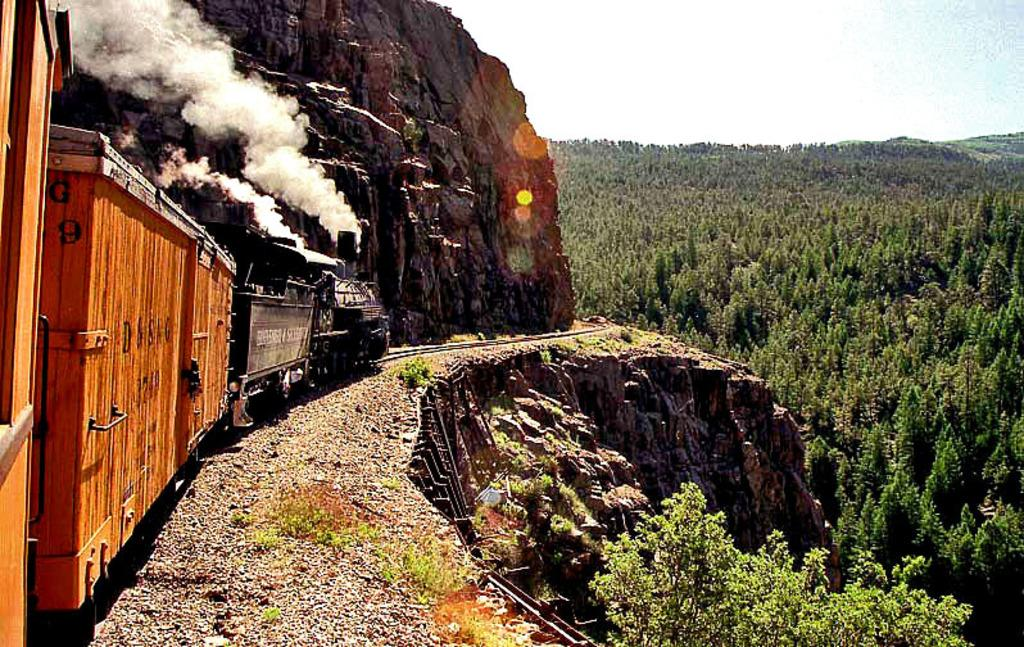What is the main subject of the image? The main subject of the image is a track on a mountain. What is located on the track in the image? There is a train on the track. What can be seen in the background of the image? There are trees and the sky visible in the background of the image. What type of skate is being used by the train in the image? There is no skate present in the image; the train is on a track. Can you see any cracks in the train or the track in the image? The image does not show any cracks in the train or the track. 